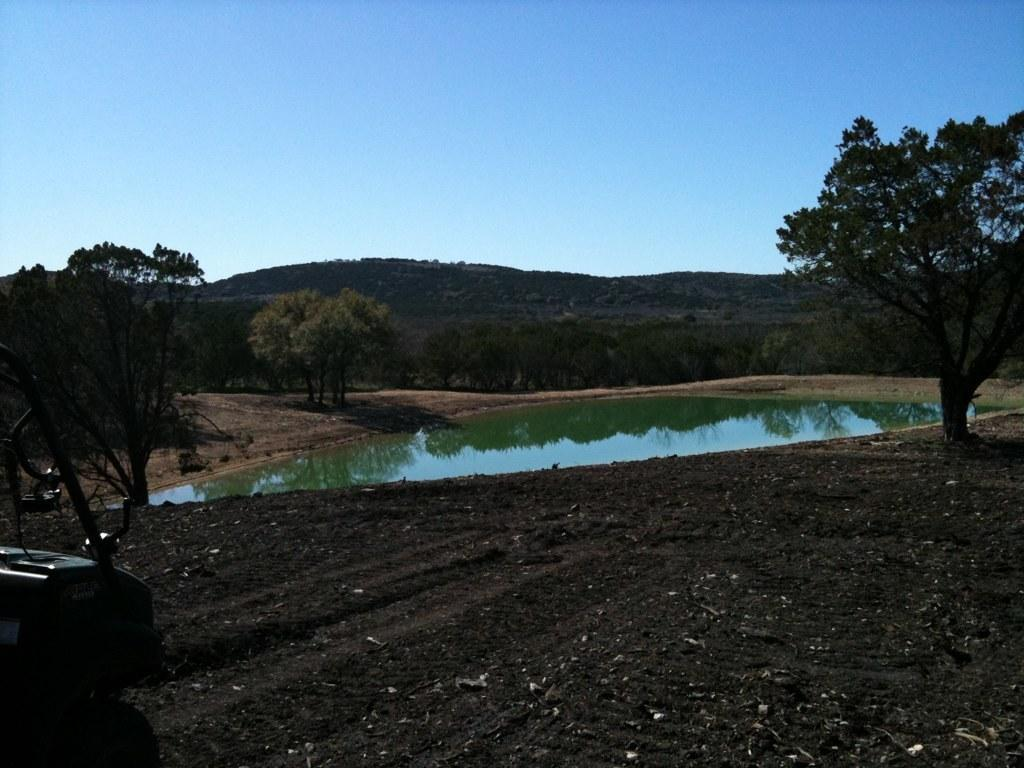What is located on the ground in the image? There is a vehicle on the ground in the image. What body of water is present in the image? There is a pond in the image. What type of vegetation surrounds the pond? There are trees around the pond. What can be seen in the distance in the image? There are mountains visible in the background of the image. What else is visible in the background of the image? The sky is visible in the background of the image. What scientific discovery is being made near the pond in the image? There is no indication of a scientific discovery being made in the image; it simply shows a vehicle, a pond, trees, mountains, and the sky. What decision is being made by the trees around the pond in the image? Trees do not make decisions, as they are inanimate objects. The image only shows the trees surrounding the pond. 